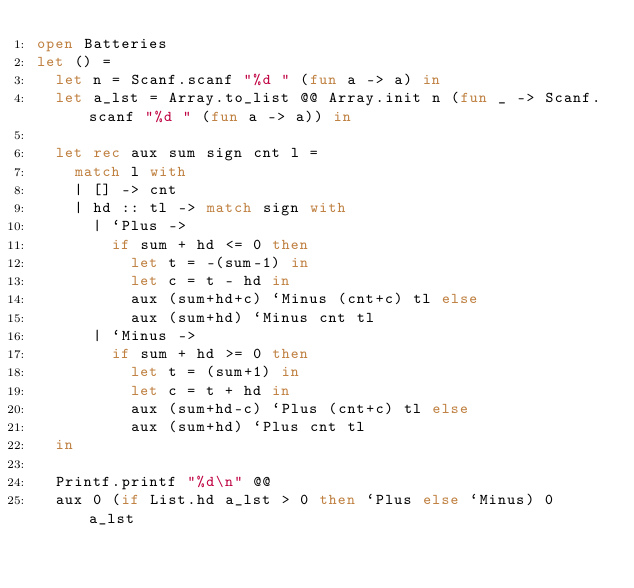Convert code to text. <code><loc_0><loc_0><loc_500><loc_500><_OCaml_>open Batteries
let () =
  let n = Scanf.scanf "%d " (fun a -> a) in
  let a_lst = Array.to_list @@ Array.init n (fun _ -> Scanf.scanf "%d " (fun a -> a)) in

  let rec aux sum sign cnt l =
    match l with
    | [] -> cnt
    | hd :: tl -> match sign with
      | `Plus -> 
        if sum + hd <= 0 then 
          let t = -(sum-1) in
          let c = t - hd in
          aux (sum+hd+c) `Minus (cnt+c) tl else 
          aux (sum+hd) `Minus cnt tl
      | `Minus -> 
        if sum + hd >= 0 then 
          let t = (sum+1) in
          let c = t + hd in
          aux (sum+hd-c) `Plus (cnt+c) tl else 
          aux (sum+hd) `Plus cnt tl
  in

  Printf.printf "%d\n" @@
  aux 0 (if List.hd a_lst > 0 then `Plus else `Minus) 0 a_lst

</code> 